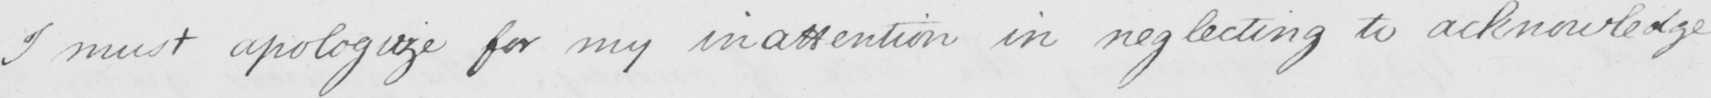Please provide the text content of this handwritten line. I must apologize for my inattention in neglecting to acknowledge 